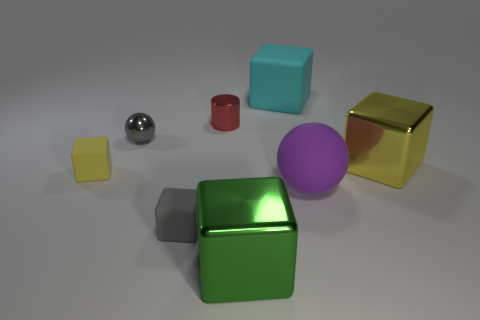What could be the purpose of arranging these objects in this way? This arrangement appears to be a study in contrasts and comparisons, perhaps for an educational purpose to demonstrate different geometric shapes, colors, and materials. It could also be a visual composition exercise focusing on balance, symmetry, and the interplay of objects in a 3D space. In terms of design, what does the diversity of colors and shapes suggest to you? The variety of colors and shapes suggests a playful and creative approach to design, encouraging the viewer to appreciate the uniqueness of each object. It evokes a sense of curiosity and exploration in the realm of visual art or product design. 